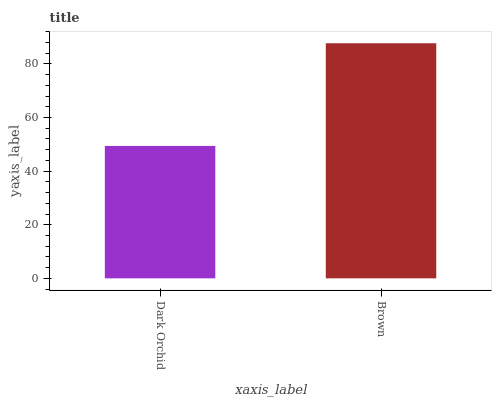Is Dark Orchid the minimum?
Answer yes or no. Yes. Is Brown the maximum?
Answer yes or no. Yes. Is Brown the minimum?
Answer yes or no. No. Is Brown greater than Dark Orchid?
Answer yes or no. Yes. Is Dark Orchid less than Brown?
Answer yes or no. Yes. Is Dark Orchid greater than Brown?
Answer yes or no. No. Is Brown less than Dark Orchid?
Answer yes or no. No. Is Brown the high median?
Answer yes or no. Yes. Is Dark Orchid the low median?
Answer yes or no. Yes. Is Dark Orchid the high median?
Answer yes or no. No. Is Brown the low median?
Answer yes or no. No. 